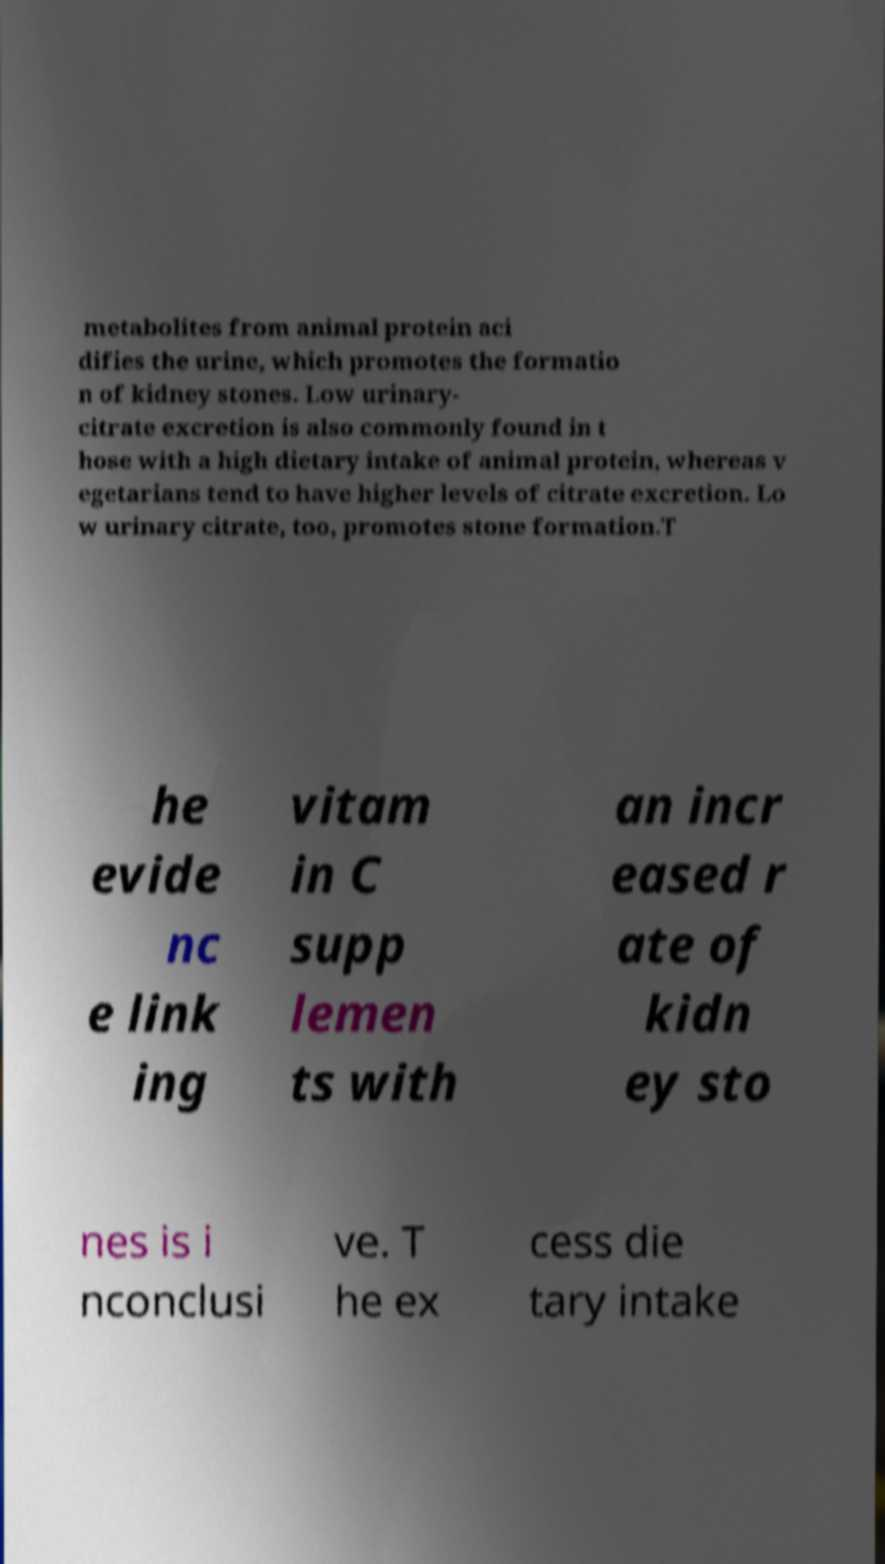There's text embedded in this image that I need extracted. Can you transcribe it verbatim? metabolites from animal protein aci difies the urine, which promotes the formatio n of kidney stones. Low urinary- citrate excretion is also commonly found in t hose with a high dietary intake of animal protein, whereas v egetarians tend to have higher levels of citrate excretion. Lo w urinary citrate, too, promotes stone formation.T he evide nc e link ing vitam in C supp lemen ts with an incr eased r ate of kidn ey sto nes is i nconclusi ve. T he ex cess die tary intake 